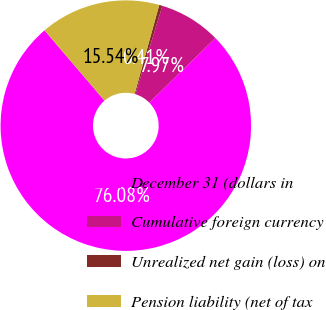<chart> <loc_0><loc_0><loc_500><loc_500><pie_chart><fcel>December 31 (dollars in<fcel>Cumulative foreign currency<fcel>Unrealized net gain (loss) on<fcel>Pension liability (net of tax<nl><fcel>76.08%<fcel>7.97%<fcel>0.41%<fcel>15.54%<nl></chart> 